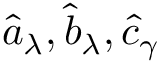<formula> <loc_0><loc_0><loc_500><loc_500>\hat { a } _ { \lambda } , \hat { b } _ { \lambda } , \hat { c } _ { \gamma }</formula> 